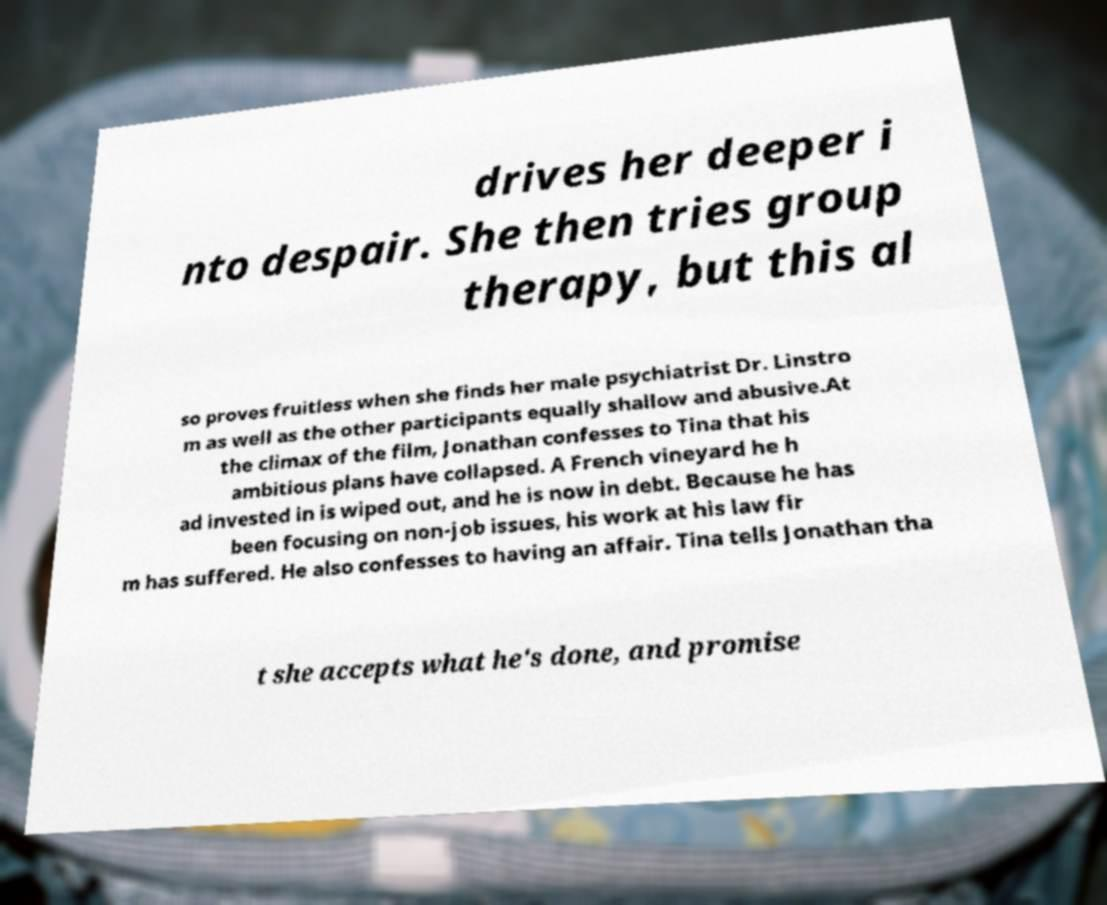I need the written content from this picture converted into text. Can you do that? drives her deeper i nto despair. She then tries group therapy, but this al so proves fruitless when she finds her male psychiatrist Dr. Linstro m as well as the other participants equally shallow and abusive.At the climax of the film, Jonathan confesses to Tina that his ambitious plans have collapsed. A French vineyard he h ad invested in is wiped out, and he is now in debt. Because he has been focusing on non-job issues, his work at his law fir m has suffered. He also confesses to having an affair. Tina tells Jonathan tha t she accepts what he's done, and promise 